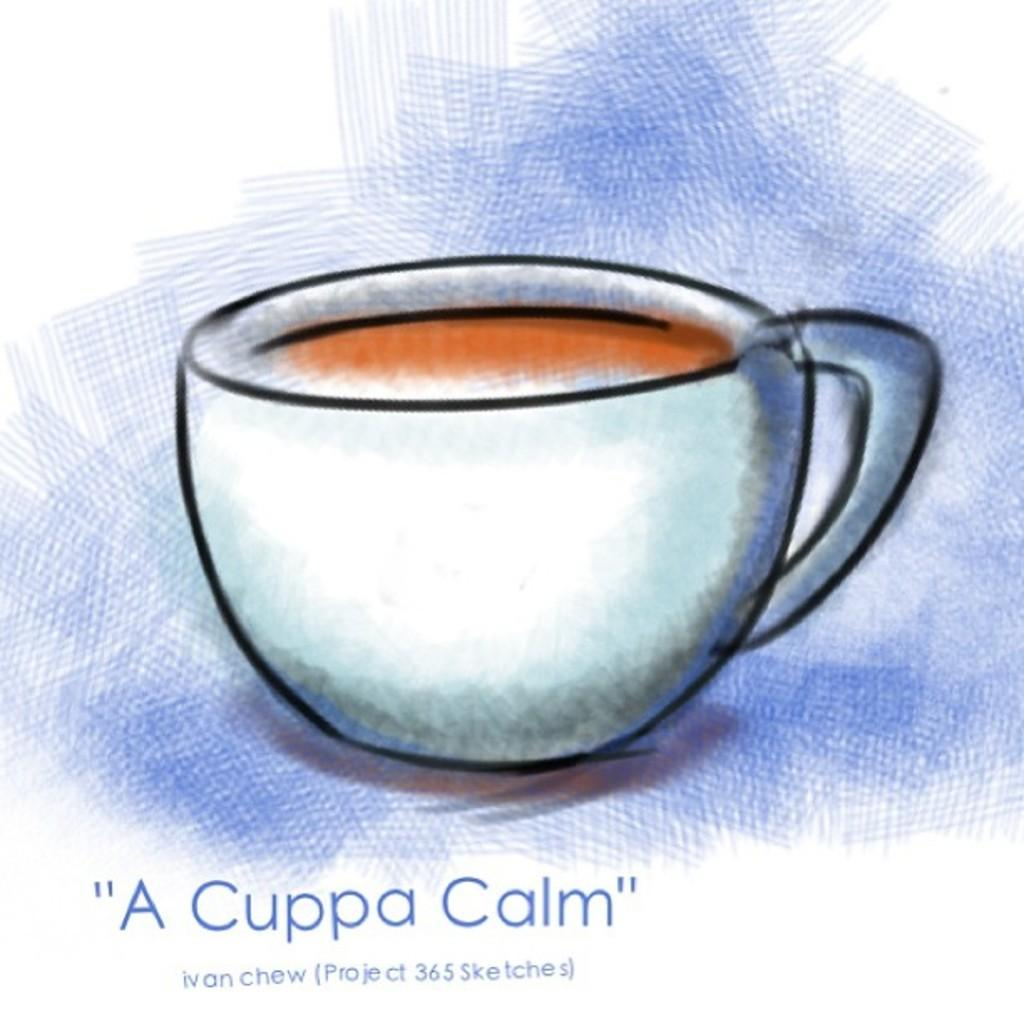What is the main subject of the image? There is a graphical image of a cup in the image. What color is the background of the image? The background of the image is blue. Is there any text present in the image? Yes, there is text at the bottom of the image. How many ornaments are hanging from the tent in the image? There is no tent or ornaments present in the image. What type of calendar is visible in the image? There is no calendar present in the image. 